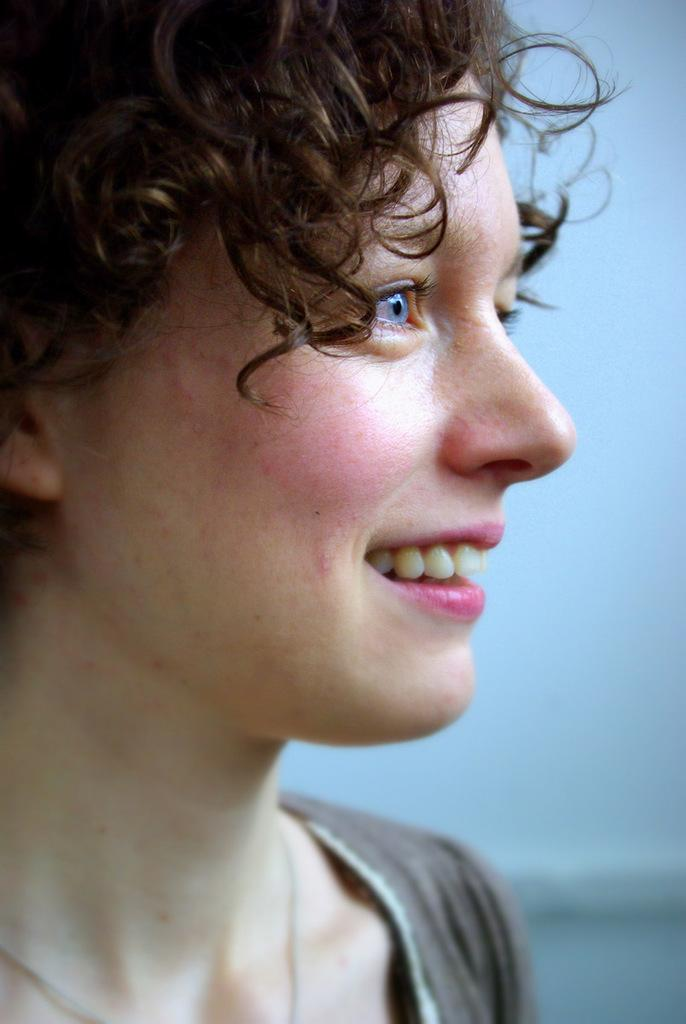What is the main subject of the image? There is a person in the image. In which direction is the person facing? The person is facing towards the right. What is the person's facial expression in the image? The person is smiling. What type of headphones can be seen on the person's head in the image? There are no headphones visible on the person's head in the image. 